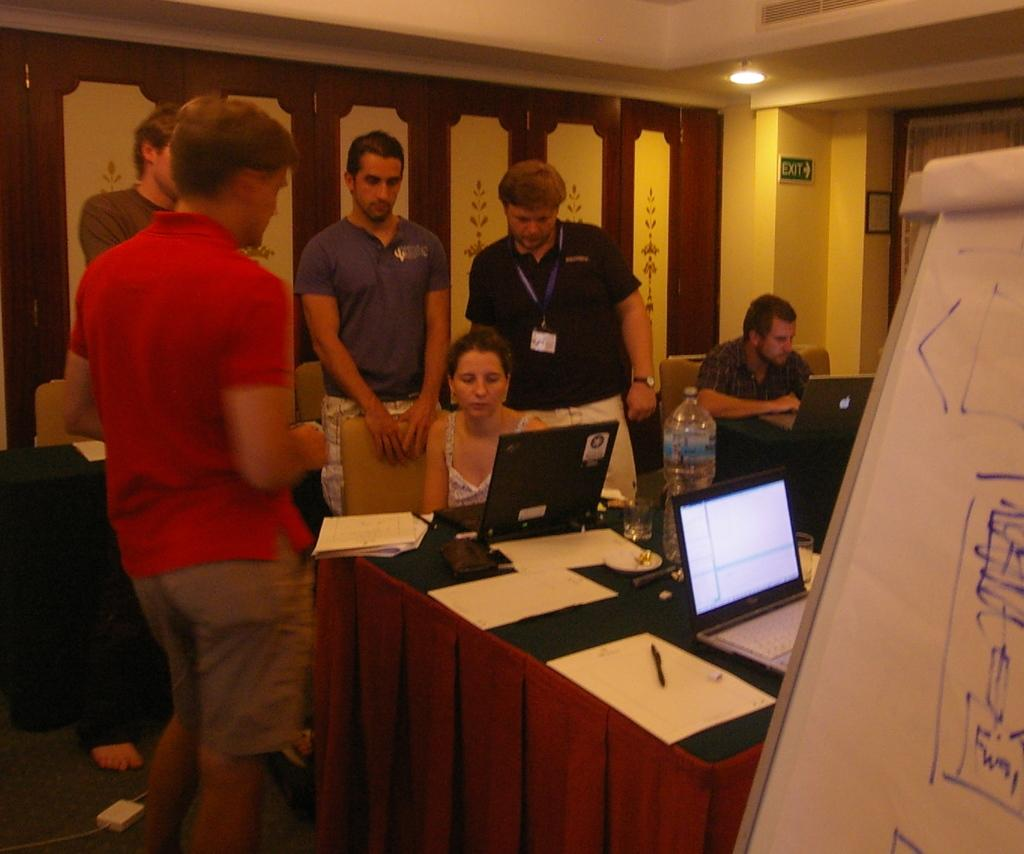What are the people in the image doing? There are people standing in the image. Can you describe the seating arrangement in the image? There is a woman sitting on a chair and a man sitting on a chair. What objects are on the table in the image? There are laptops on a table. What type of lumber is being used to construct the chairs in the image? There is no information about the material of the chairs in the image, so it cannot be determined. Can you describe the smiles on the faces of the people in the image? There is no mention of smiles or facial expressions in the image, so it cannot be described. 